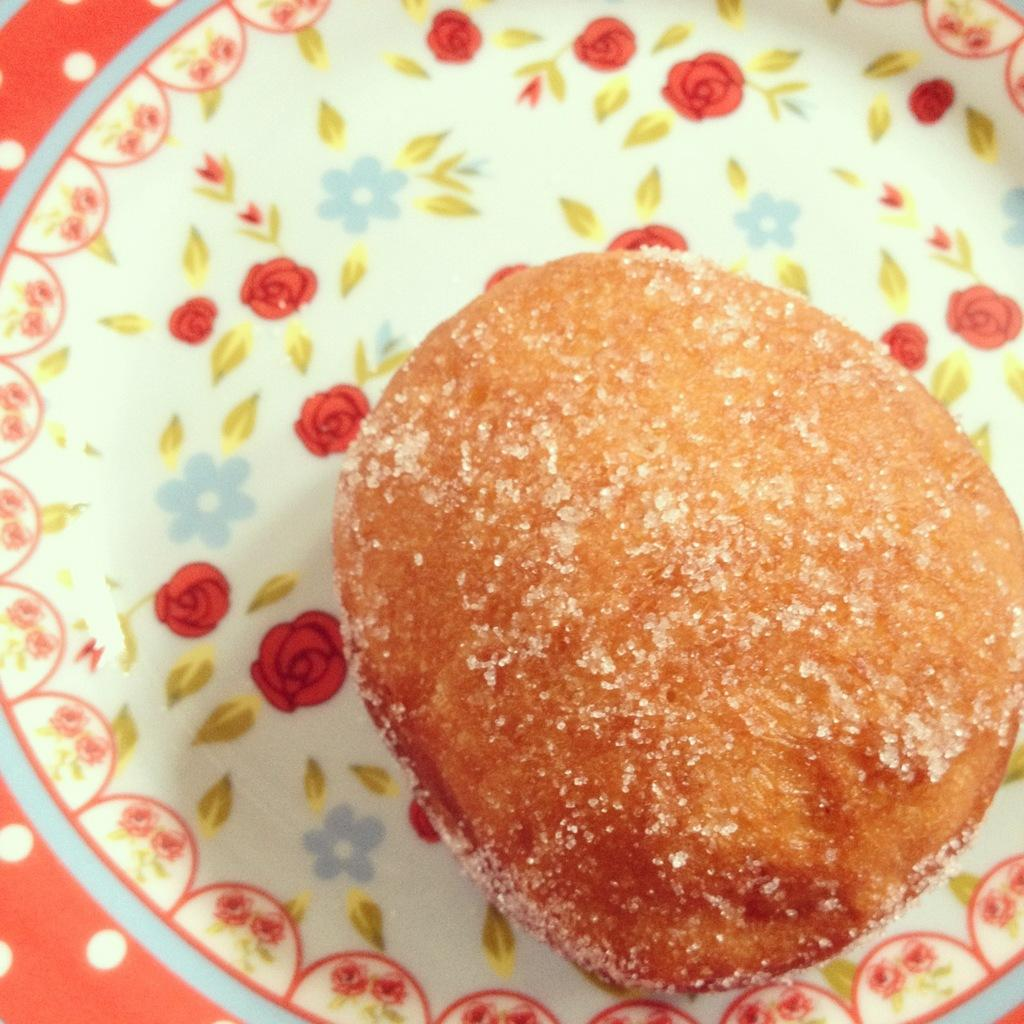What is on the plate in the image? There is a food item on a plate in the image. Can you describe the design on the plate? The plate has designs of flowers. Where is the cactus located in the image? There is no cactus present in the image. What type of meal is being prepared in the image? The image does not show any meal preparation or cooking; it only shows a plate with a food item and a plate with flower designs. 